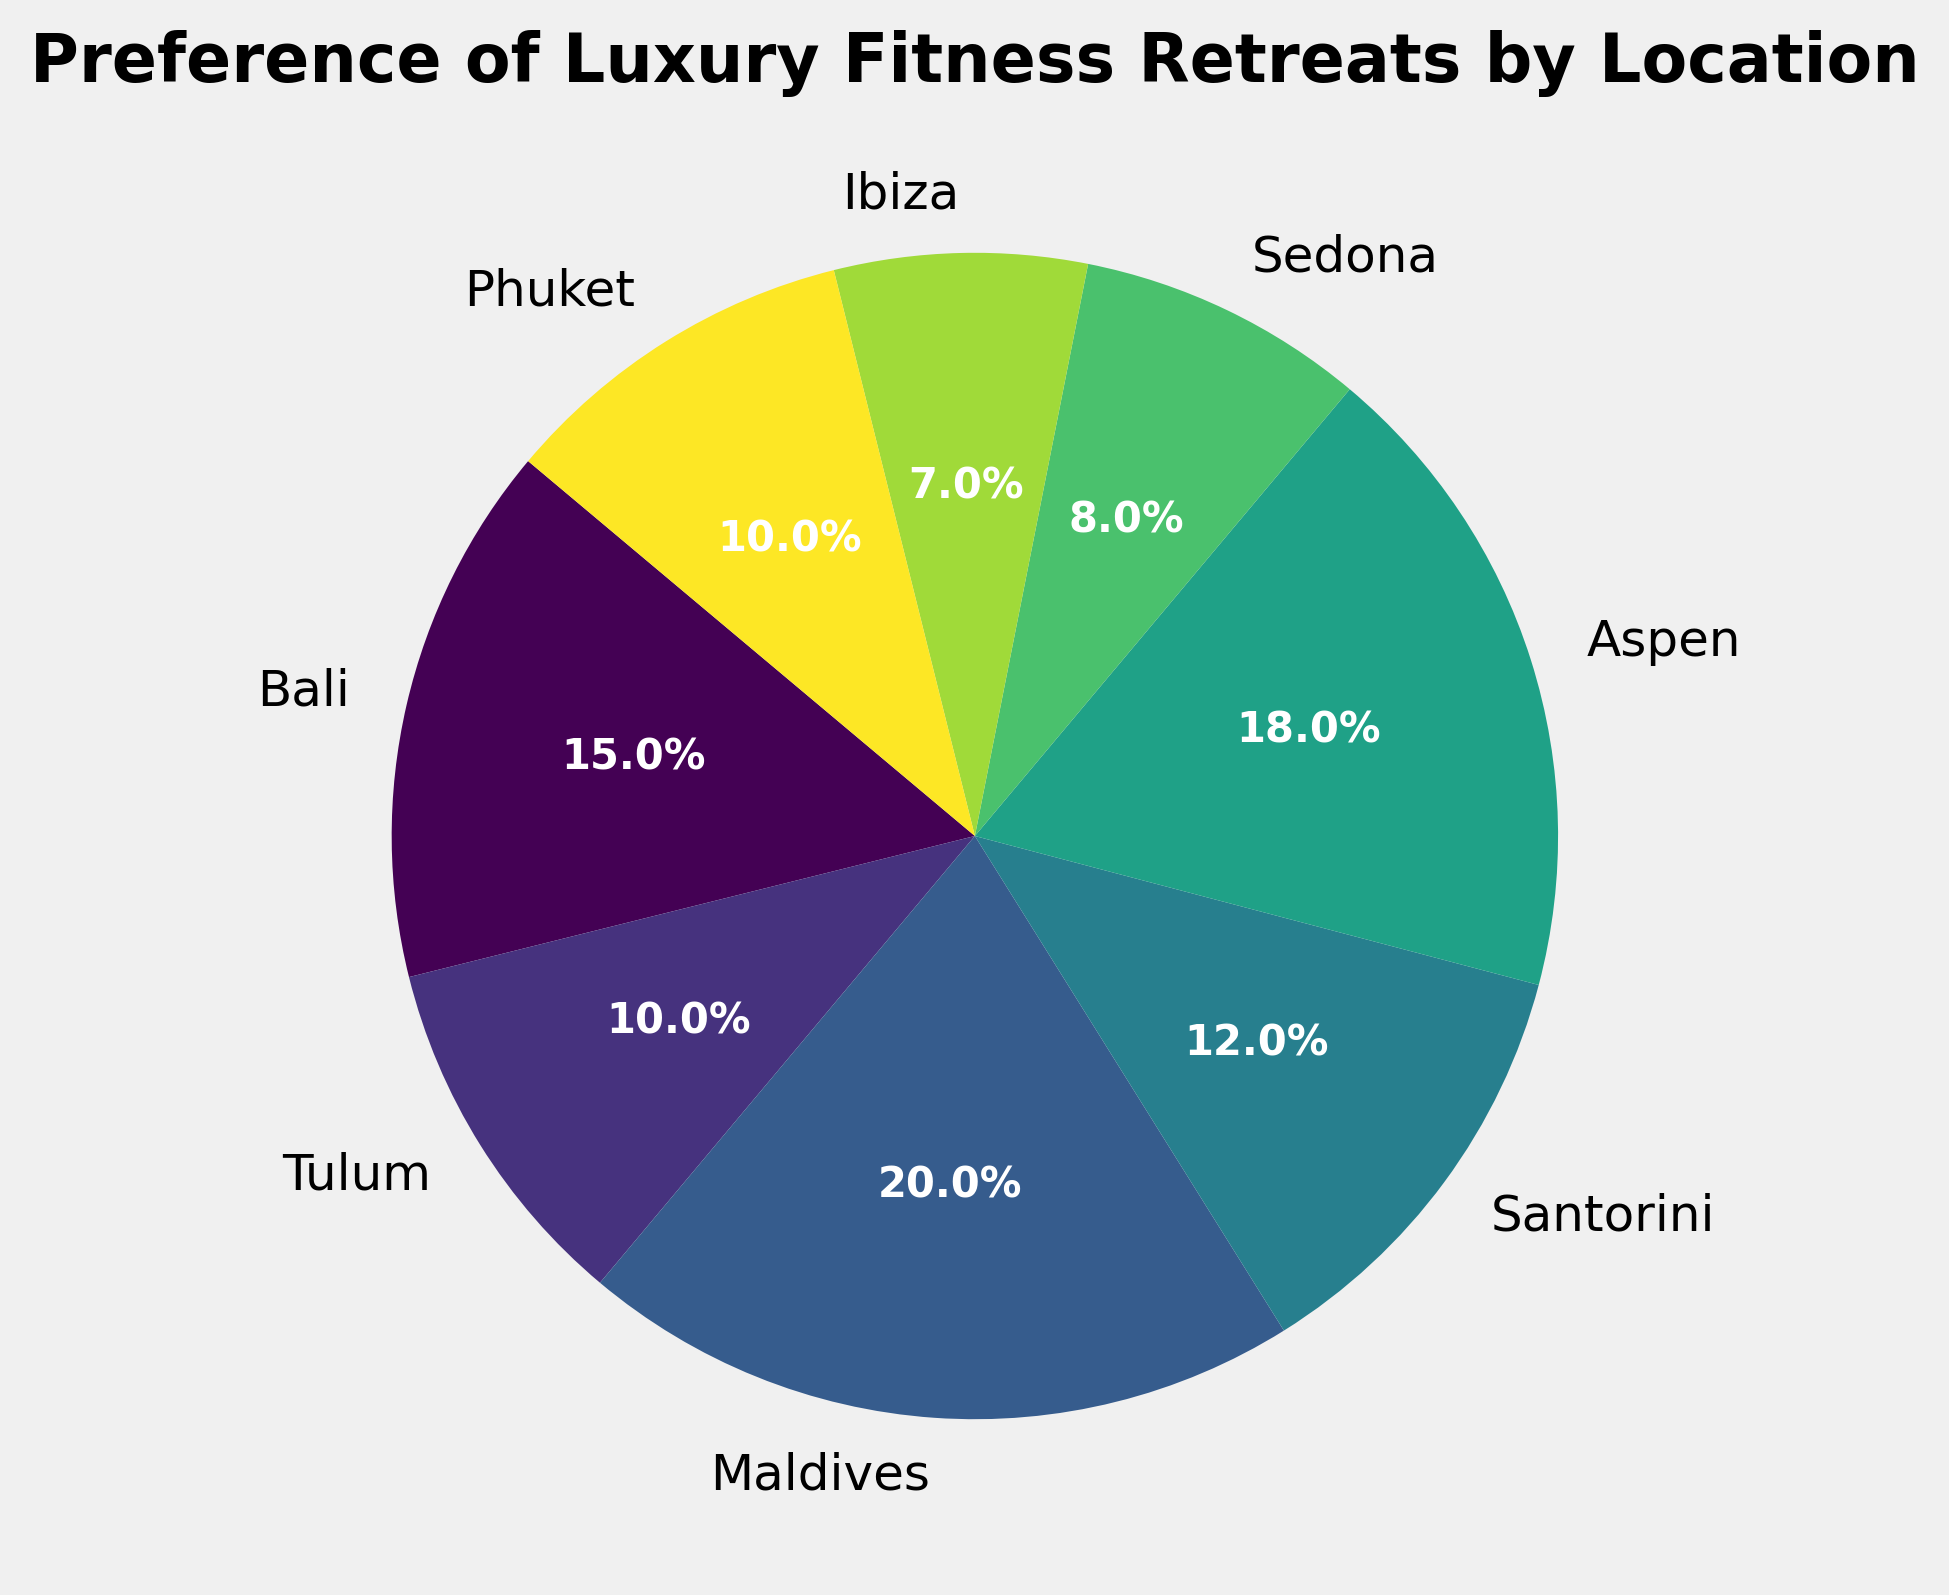What are the top three most preferred locations for luxury fitness retreats? The locations are ranked in descending order by their preference percentages. According to the pie chart, the three locations with the highest preference percentages are Maldives (20%), Aspen (18%), and Bali (15%).
Answer: Maldives, Aspen, Bali Which location has the least preference for luxury fitness retreats? By looking at the pie chart, Ibiza has the smallest segment, indicating the lowest preference percentage at 7%.
Answer: Ibiza How much more preferred is Maldives than Sedona for luxury fitness retreats? Maldives has a preference percentage of 20%, and Sedona has 8%. The difference between the two is 20% - 8% = 12%.
Answer: 12% Is the combined preference of Tulum and Phuket higher or lower than Aspen? Tulum has a preference percentage of 10%, and Phuket also has 10%. Their combined preference is 10% + 10% = 20%, which is higher than Aspen's 18%.
Answer: Higher What is the total preference percentage for European locations (Santorini and Ibiza)? Santorini has a preference of 12%, and Ibiza has 7%. The combined preference for these European locations is 12% + 7% = 19%.
Answer: 19% How does the preference for Santorini compare to that for Aspen? Santorini has a preference percentage of 12%, while Aspen has 18%. Thus, Aspen's preference is higher than Santorini's by 18% - 12% = 6%.
Answer: Aspen is 6% higher What is the average preference percentage of all locations? The preference percentages are: 15%, 10%, 20%, 12%, 18%, 8%, 7%, and 10%. The sum of these percentages is 100%. The average can be calculated as 100% / 8 locations = 12.5%.
Answer: 12.5% Which location has a preference closest to Tulum? Tulum has a preference percentage of 10%. By comparing the other percentages, Phuket also has a preference of 10%, which is exactly the same as Tulum.
Answer: Phuket How does the combined preference of Bali and Sedona compare to Maldives? Bali has a preference percentage of 15%, and Sedona has 8%. Their combined preference is 15% + 8% = 23%, which is higher than Maldives' 20%.
Answer: Higher Which locations have a preference percentage of at least 10%? According to the pie chart, the locations with preference percentages of 10% or higher are Bali (15%), Tulum (10%), Maldives (20%), Santorini (12%), Aspen (18%), and Phuket (10%).
Answer: Bali, Tulum, Maldives, Santorini, Aspen, Phuket 